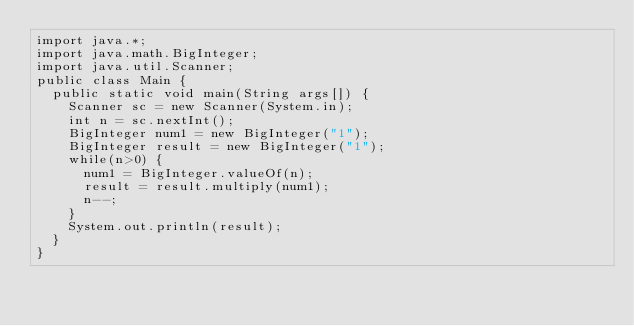Convert code to text. <code><loc_0><loc_0><loc_500><loc_500><_Java_>import java.*;
import java.math.BigInteger;
import java.util.Scanner;
public class Main {
	public static void main(String args[]) {
		Scanner sc = new Scanner(System.in);
		int n = sc.nextInt();
		BigInteger num1 = new BigInteger("1");
		BigInteger result = new BigInteger("1");
		while(n>0) {
			num1 = BigInteger.valueOf(n);
			result = result.multiply(num1);
			n--;
		}
		System.out.println(result);
	}
}</code> 